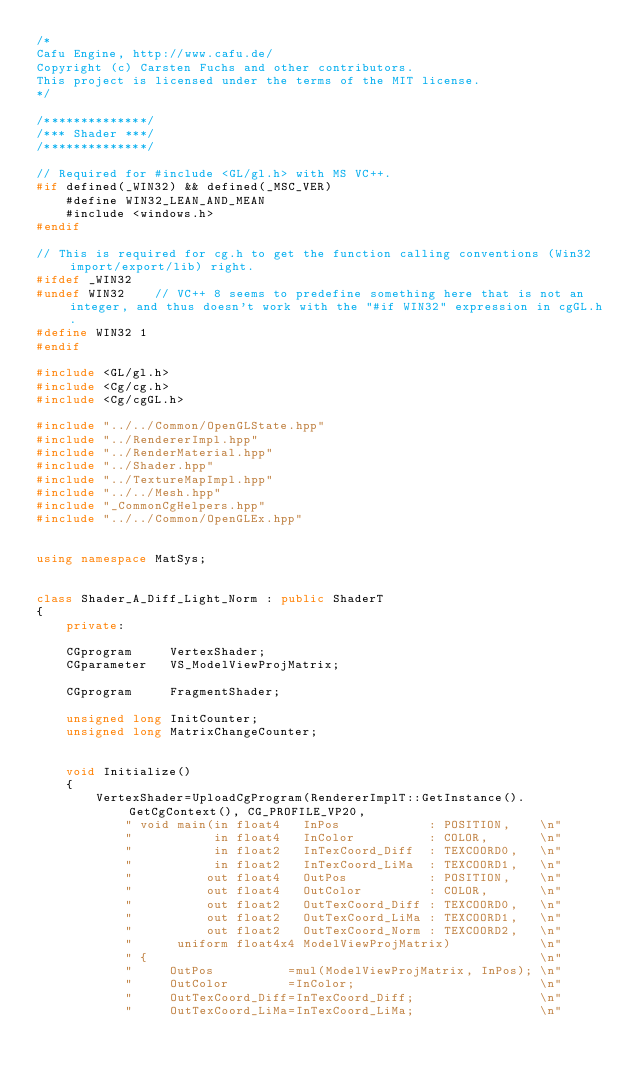<code> <loc_0><loc_0><loc_500><loc_500><_C++_>/*
Cafu Engine, http://www.cafu.de/
Copyright (c) Carsten Fuchs and other contributors.
This project is licensed under the terms of the MIT license.
*/

/**************/
/*** Shader ***/
/**************/

// Required for #include <GL/gl.h> with MS VC++.
#if defined(_WIN32) && defined(_MSC_VER)
    #define WIN32_LEAN_AND_MEAN
    #include <windows.h>
#endif

// This is required for cg.h to get the function calling conventions (Win32 import/export/lib) right.
#ifdef _WIN32
#undef WIN32    // VC++ 8 seems to predefine something here that is not an integer, and thus doesn't work with the "#if WIN32" expression in cgGL.h.
#define WIN32 1
#endif

#include <GL/gl.h>
#include <Cg/cg.h>
#include <Cg/cgGL.h>

#include "../../Common/OpenGLState.hpp"
#include "../RendererImpl.hpp"
#include "../RenderMaterial.hpp"
#include "../Shader.hpp"
#include "../TextureMapImpl.hpp"
#include "../../Mesh.hpp"
#include "_CommonCgHelpers.hpp"
#include "../../Common/OpenGLEx.hpp"


using namespace MatSys;


class Shader_A_Diff_Light_Norm : public ShaderT
{
    private:

    CGprogram     VertexShader;
    CGparameter   VS_ModelViewProjMatrix;

    CGprogram     FragmentShader;

    unsigned long InitCounter;
    unsigned long MatrixChangeCounter;


    void Initialize()
    {
        VertexShader=UploadCgProgram(RendererImplT::GetInstance().GetCgContext(), CG_PROFILE_VP20,
            " void main(in float4   InPos            : POSITION,    \n"
            "           in float4   InColor          : COLOR,       \n"
            "           in float2   InTexCoord_Diff  : TEXCOORD0,   \n"
            "           in float2   InTexCoord_LiMa  : TEXCOORD1,   \n"
            "          out float4   OutPos           : POSITION,    \n"
            "          out float4   OutColor         : COLOR,       \n"
            "          out float2   OutTexCoord_Diff : TEXCOORD0,   \n"
            "          out float2   OutTexCoord_LiMa : TEXCOORD1,   \n"
            "          out float2   OutTexCoord_Norm : TEXCOORD2,   \n"
            "      uniform float4x4 ModelViewProjMatrix)            \n"
            " {                                                     \n"
            "     OutPos          =mul(ModelViewProjMatrix, InPos); \n"
            "     OutColor        =InColor;                         \n"
            "     OutTexCoord_Diff=InTexCoord_Diff;                 \n"
            "     OutTexCoord_LiMa=InTexCoord_LiMa;                 \n"</code> 